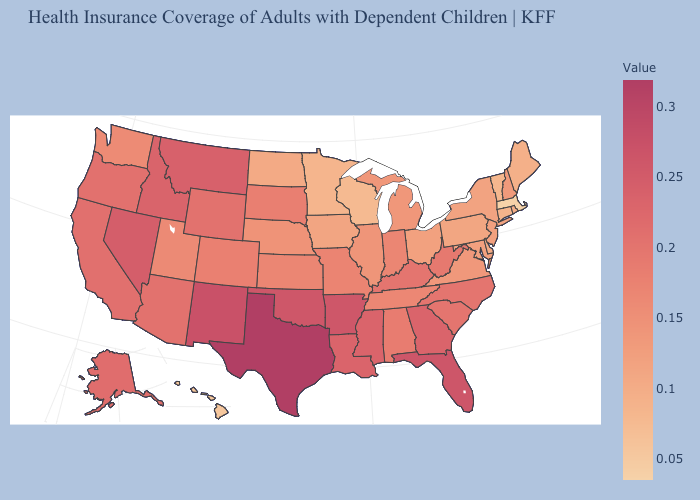Which states have the lowest value in the USA?
Give a very brief answer. Massachusetts. Which states have the lowest value in the West?
Keep it brief. Hawaii. Does Texas have the highest value in the USA?
Keep it brief. Yes. Among the states that border Pennsylvania , which have the highest value?
Short answer required. West Virginia. 